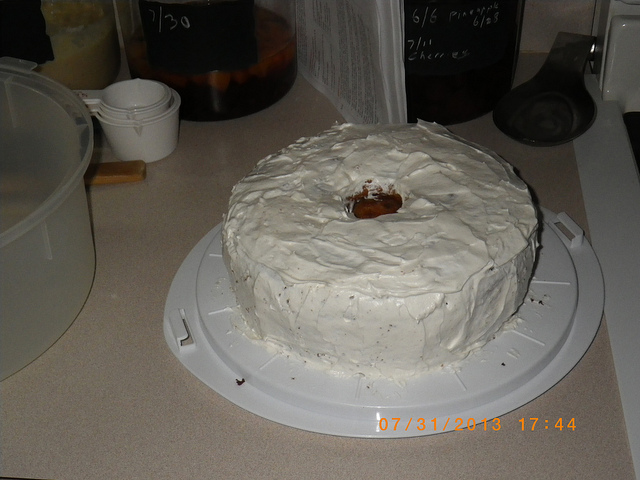Identify the text displayed in this image. 6 7 44 17 2013 31 07 30 